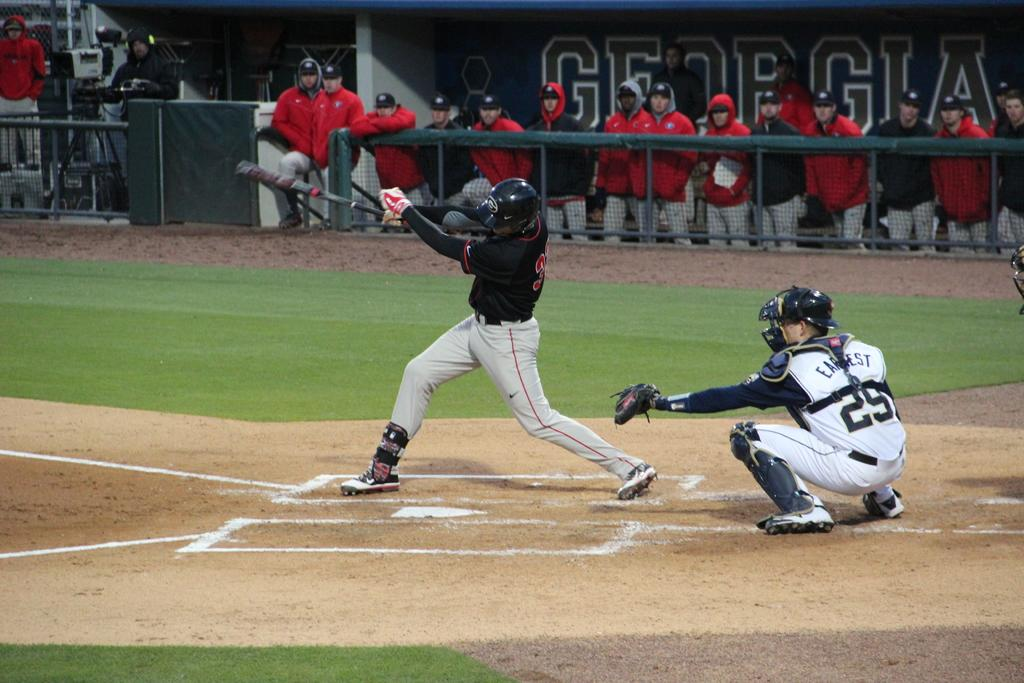<image>
Relay a brief, clear account of the picture shown. GEORGIA is writen on a banner behind the team in the dug out. 